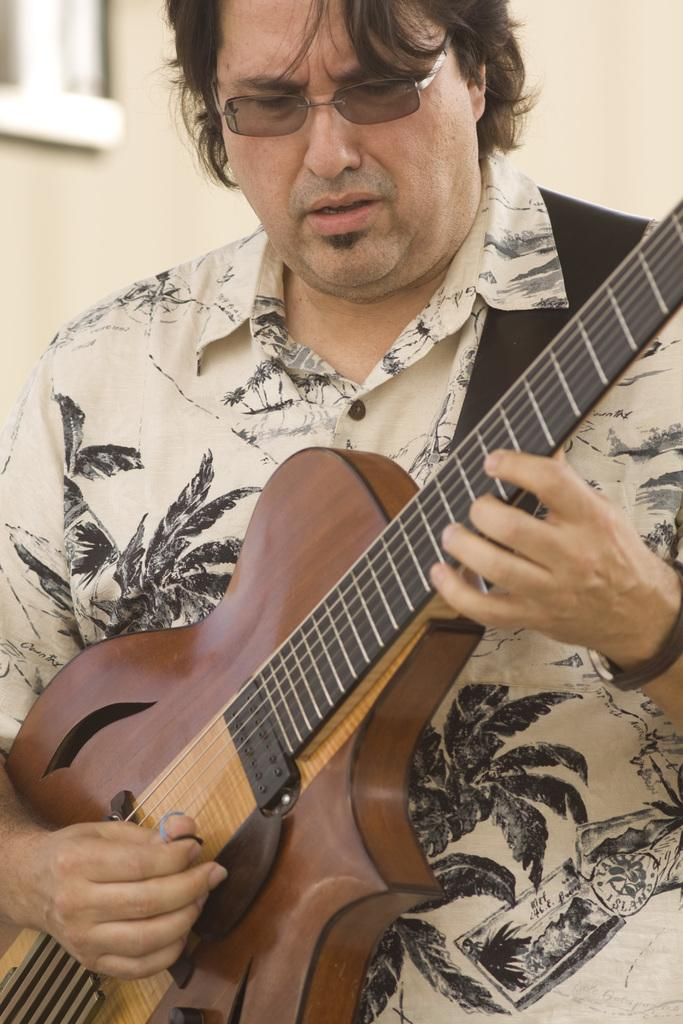What is the man in the image holding? The man is holding a guitar. What is the man wearing on his upper body? The man is wearing a printed shirt. What accessory is the man wearing on his face? The man is wearing spectacles. What can be seen in the background of the image? There is a wall in the background of the image. What type of pest can be seen crawling on the wall in the image? There are no pests visible in the image; the wall in the background is clear of any insects or animals. 